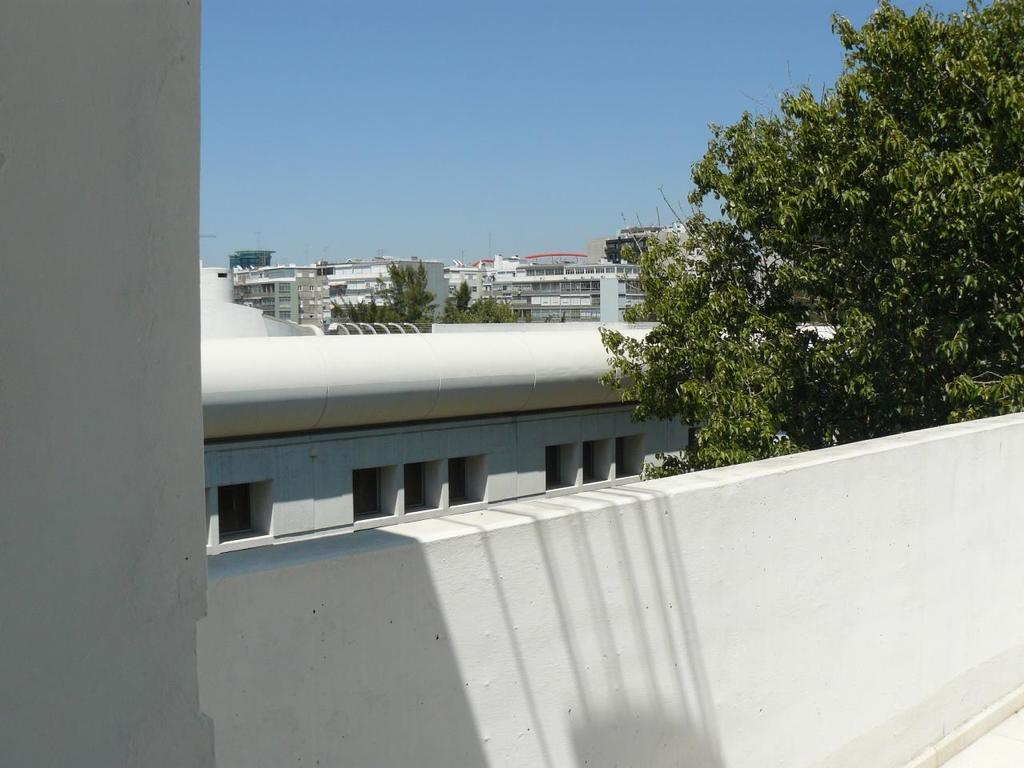What is the main structure visible in the image? There is a wall in the image. What can be seen behind the wall? There are trees and buildings behind the wall. What is visible at the top of the image? The sky is visible at the top of the image. Where is the cemetery located in the image? There is no cemetery present in the image. Is there any evidence of war in the image? There is no indication of war in the image. 